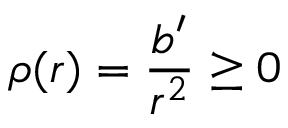<formula> <loc_0><loc_0><loc_500><loc_500>\rho ( r ) = \frac { b ^ { \prime } } { r ^ { 2 } } \geq 0</formula> 